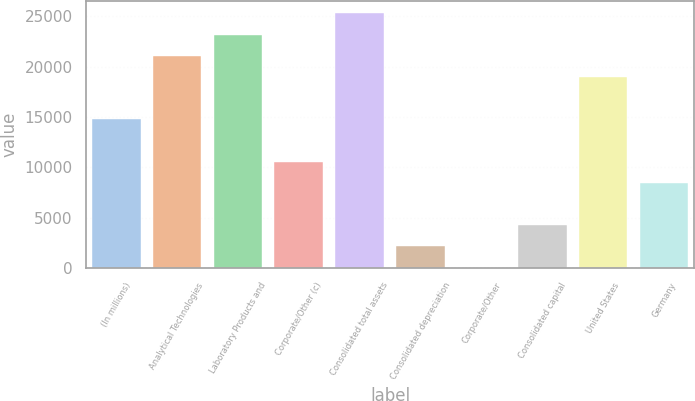<chart> <loc_0><loc_0><loc_500><loc_500><bar_chart><fcel>(In millions)<fcel>Analytical Technologies<fcel>Laboratory Products and<fcel>Corporate/Other (c)<fcel>Consolidated total assets<fcel>Consolidated depreciation<fcel>Corporate/Other<fcel>Consolidated capital<fcel>United States<fcel>Germany<nl><fcel>14766.5<fcel>21090<fcel>23197.8<fcel>10550.9<fcel>25305.6<fcel>2119.62<fcel>11.8<fcel>4227.44<fcel>18982.2<fcel>8443.08<nl></chart> 